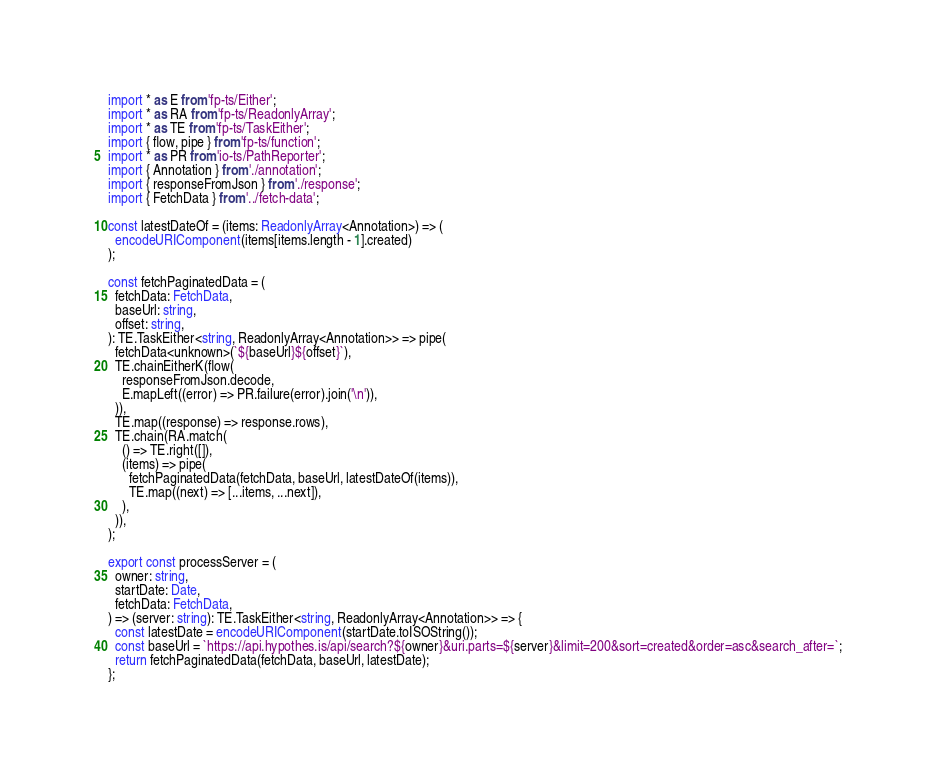<code> <loc_0><loc_0><loc_500><loc_500><_TypeScript_>import * as E from 'fp-ts/Either';
import * as RA from 'fp-ts/ReadonlyArray';
import * as TE from 'fp-ts/TaskEither';
import { flow, pipe } from 'fp-ts/function';
import * as PR from 'io-ts/PathReporter';
import { Annotation } from './annotation';
import { responseFromJson } from './response';
import { FetchData } from '../fetch-data';

const latestDateOf = (items: ReadonlyArray<Annotation>) => (
  encodeURIComponent(items[items.length - 1].created)
);

const fetchPaginatedData = (
  fetchData: FetchData,
  baseUrl: string,
  offset: string,
): TE.TaskEither<string, ReadonlyArray<Annotation>> => pipe(
  fetchData<unknown>(`${baseUrl}${offset}`),
  TE.chainEitherK(flow(
    responseFromJson.decode,
    E.mapLeft((error) => PR.failure(error).join('\n')),
  )),
  TE.map((response) => response.rows),
  TE.chain(RA.match(
    () => TE.right([]),
    (items) => pipe(
      fetchPaginatedData(fetchData, baseUrl, latestDateOf(items)),
      TE.map((next) => [...items, ...next]),
    ),
  )),
);

export const processServer = (
  owner: string,
  startDate: Date,
  fetchData: FetchData,
) => (server: string): TE.TaskEither<string, ReadonlyArray<Annotation>> => {
  const latestDate = encodeURIComponent(startDate.toISOString());
  const baseUrl = `https://api.hypothes.is/api/search?${owner}&uri.parts=${server}&limit=200&sort=created&order=asc&search_after=`;
  return fetchPaginatedData(fetchData, baseUrl, latestDate);
};
</code> 